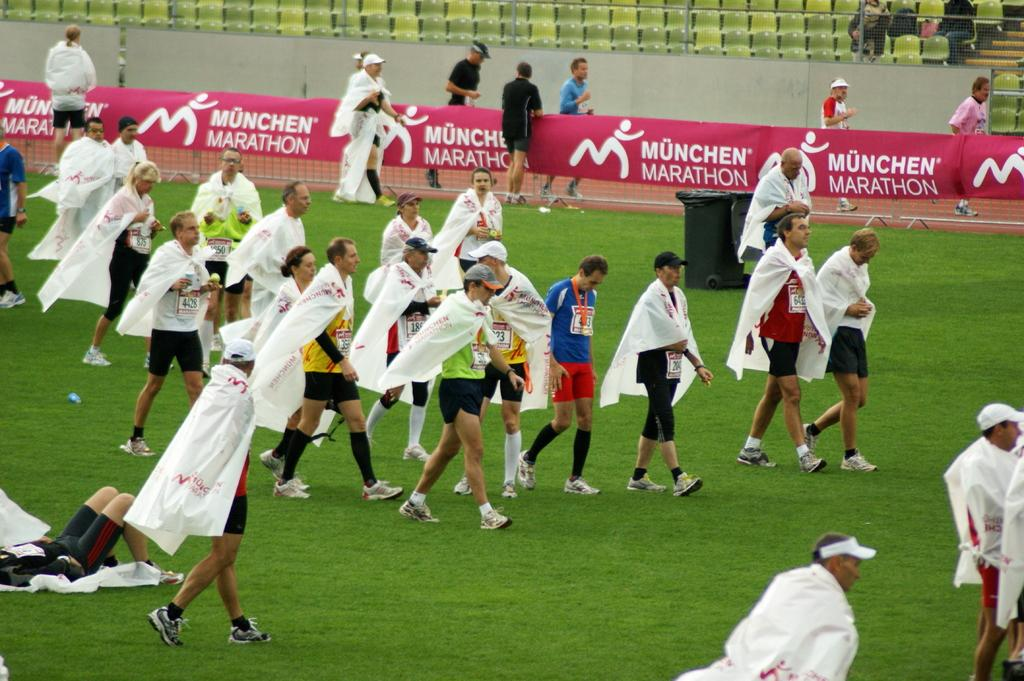<image>
Write a terse but informative summary of the picture. Competitors and spectators alike all enjoy spending their day at the Munchen Marathon. 